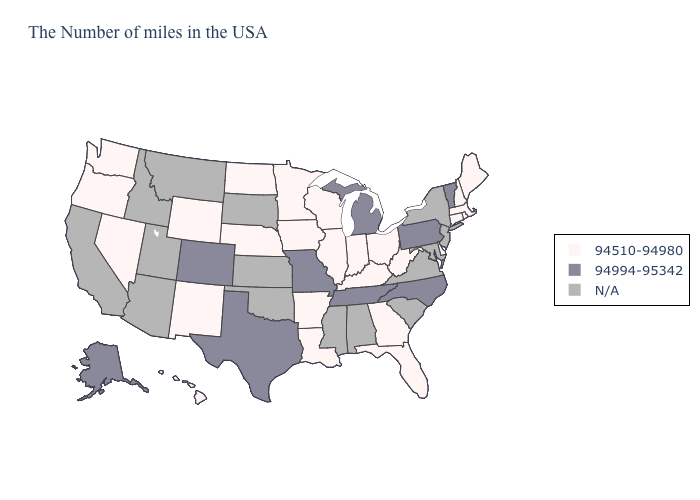Name the states that have a value in the range 94994-95342?
Be succinct. Vermont, Pennsylvania, North Carolina, Michigan, Tennessee, Missouri, Texas, Colorado, Alaska. Name the states that have a value in the range 94510-94980?
Keep it brief. Maine, Massachusetts, Rhode Island, New Hampshire, Connecticut, Delaware, West Virginia, Ohio, Florida, Georgia, Kentucky, Indiana, Wisconsin, Illinois, Louisiana, Arkansas, Minnesota, Iowa, Nebraska, North Dakota, Wyoming, New Mexico, Nevada, Washington, Oregon, Hawaii. Name the states that have a value in the range 94994-95342?
Keep it brief. Vermont, Pennsylvania, North Carolina, Michigan, Tennessee, Missouri, Texas, Colorado, Alaska. What is the highest value in the Northeast ?
Be succinct. 94994-95342. Name the states that have a value in the range 94510-94980?
Give a very brief answer. Maine, Massachusetts, Rhode Island, New Hampshire, Connecticut, Delaware, West Virginia, Ohio, Florida, Georgia, Kentucky, Indiana, Wisconsin, Illinois, Louisiana, Arkansas, Minnesota, Iowa, Nebraska, North Dakota, Wyoming, New Mexico, Nevada, Washington, Oregon, Hawaii. Name the states that have a value in the range N/A?
Quick response, please. New York, New Jersey, Maryland, Virginia, South Carolina, Alabama, Mississippi, Kansas, Oklahoma, South Dakota, Utah, Montana, Arizona, Idaho, California. Which states hav the highest value in the Northeast?
Write a very short answer. Vermont, Pennsylvania. What is the highest value in the USA?
Give a very brief answer. 94994-95342. What is the highest value in the USA?
Keep it brief. 94994-95342. Name the states that have a value in the range 94510-94980?
Concise answer only. Maine, Massachusetts, Rhode Island, New Hampshire, Connecticut, Delaware, West Virginia, Ohio, Florida, Georgia, Kentucky, Indiana, Wisconsin, Illinois, Louisiana, Arkansas, Minnesota, Iowa, Nebraska, North Dakota, Wyoming, New Mexico, Nevada, Washington, Oregon, Hawaii. Among the states that border Arkansas , does Missouri have the highest value?
Concise answer only. Yes. What is the highest value in states that border Tennessee?
Quick response, please. 94994-95342. Name the states that have a value in the range 94994-95342?
Be succinct. Vermont, Pennsylvania, North Carolina, Michigan, Tennessee, Missouri, Texas, Colorado, Alaska. 